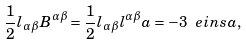<formula> <loc_0><loc_0><loc_500><loc_500>\frac { 1 } { 2 } l _ { \alpha \beta } B ^ { \alpha \beta } = \frac { 1 } { 2 } l _ { \alpha \beta } l ^ { \alpha \beta } a = - 3 \ e i n s a ,</formula> 